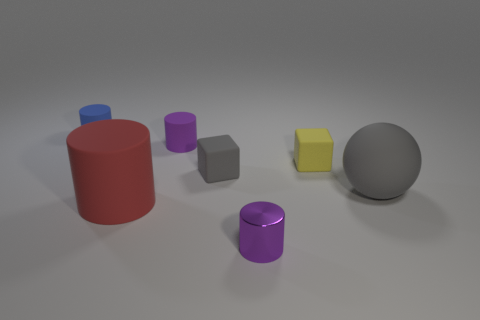Add 2 yellow blocks. How many objects exist? 9 Subtract all balls. How many objects are left? 6 Subtract all matte cylinders. Subtract all red matte things. How many objects are left? 3 Add 7 matte spheres. How many matte spheres are left? 8 Add 2 tiny metal things. How many tiny metal things exist? 3 Subtract 0 purple blocks. How many objects are left? 7 